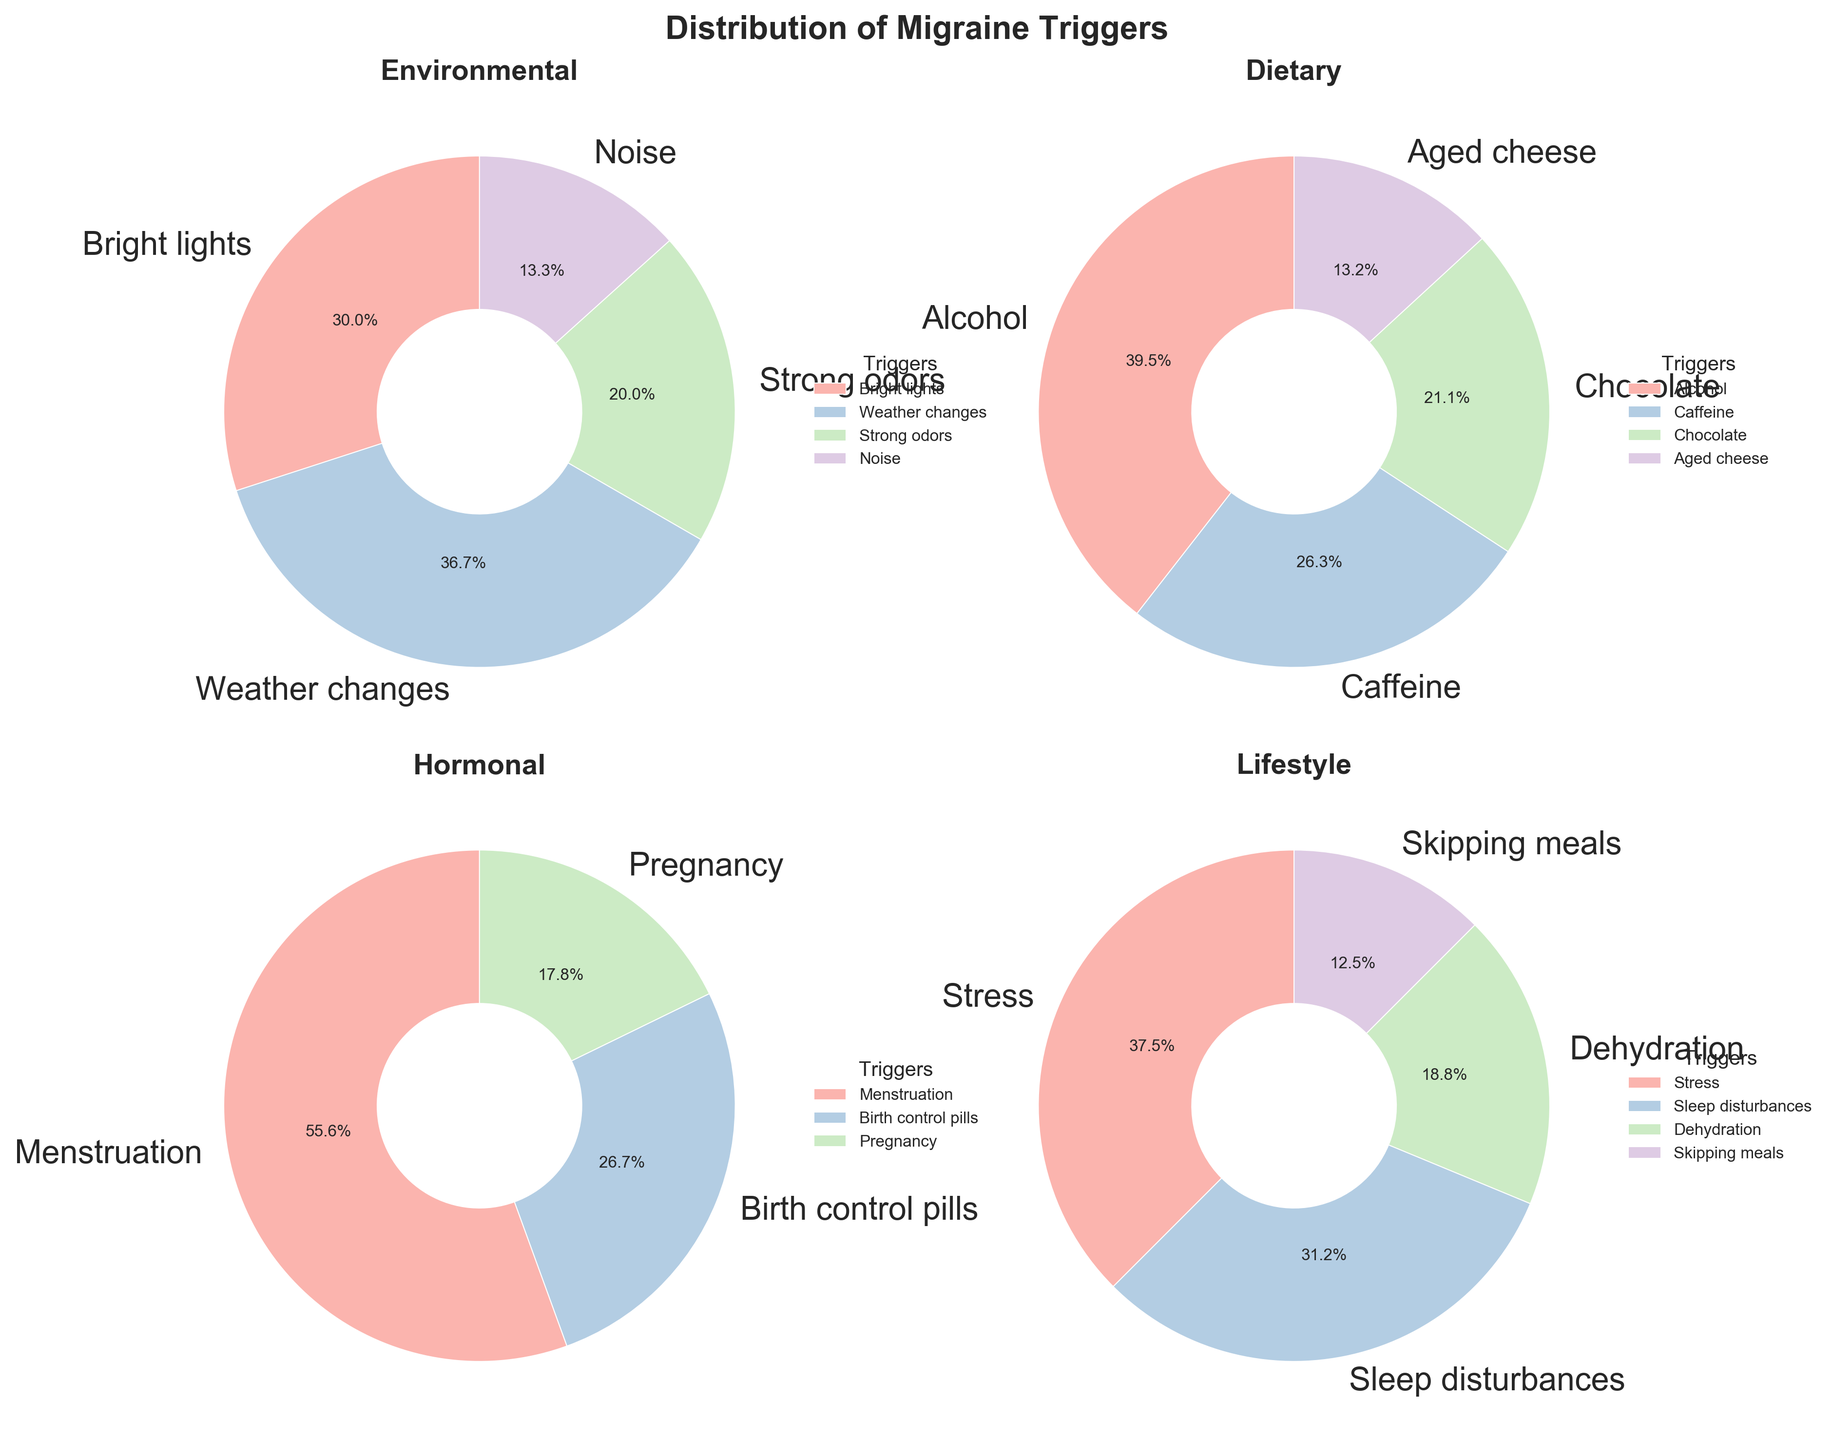What are the main categories of migraine triggers presented in the figure? There are four main categories of migraine triggers presented in the figure. These categories are Environmental, Dietary, Hormonal, and Lifestyle, each shown in individual pie charts.
Answer: Environmental, Dietary, Hormonal, Lifestyle Which trigger has the highest percentage among all categories? By inspecting each pie chart, we find that "Stress" in the Lifestyle category has the highest percentage at 30%.
Answer: Stress What is the combined percentage of triggers related to Diet? Summing up the percentages of all Dietary triggers: Alcohol (15%), Caffeine (10%), Chocolate (8%), and Aged cheese (5%) gives us a total of 38%.
Answer: 38% How do the percentages of 'Menstruation' and 'Sleep disturbances' compare? Menstruation has a percentage of 25% in the Hormonal category, while Sleep disturbances have a percentage of 25% in the Lifestyle category. Thus, they are equal.
Answer: Equal Which category has the smallest share for any single trigger, and what is it? By examining all the pie charts, we see that in the Dietary category, 'Aged cheese' has the smallest share at 5%.
Answer: Dietary, Aged cheese What is the total percentage of triggers in the Environmental category? Adding the percentages of all Environmental triggers: Bright lights (18%), Weather changes (22%), Strong odors (12%), and Noise (8%) results in 60%.
Answer: 60% Which of the hormonal triggers has the smallest contribution, and what is its percentage? In the Hormonal category, Pregnancy has the smallest contribution with a percentage of 8%.
Answer: Pregnancy, 8% How much larger is the percentage of 'Weather changes' compared to 'Strong odors' as a trigger? The percentage of Weather changes is 22% and Strong odors are 12%. The difference is 22% - 12% = 10%.
Answer: 10% What's the combined percentage of 'Noise' and 'Skipping meals' triggers? Summing up the percentages of 'Noise' (8%) from Environmental triggers and 'Skipping meals' (10%) from Lifestyle triggers gives a total of 18%.
Answer: 18% Which category has the most evenly distributed triggers based on their percentages, and why? By observing the pie charts, the Hormonal category appears most evenly distributed because the percentages (25%, 12%, and 8%) are closer to each other compared to other categories where certain triggers dominate.
Answer: Hormonal 